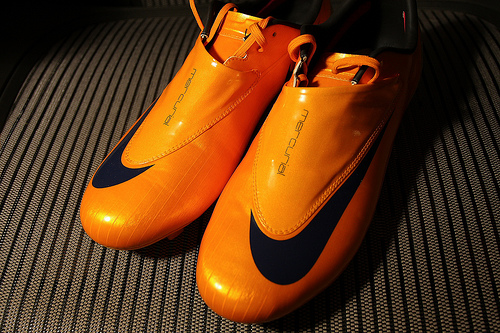<image>
Can you confirm if the zoe is on the floor? Yes. Looking at the image, I can see the zoe is positioned on top of the floor, with the floor providing support. 